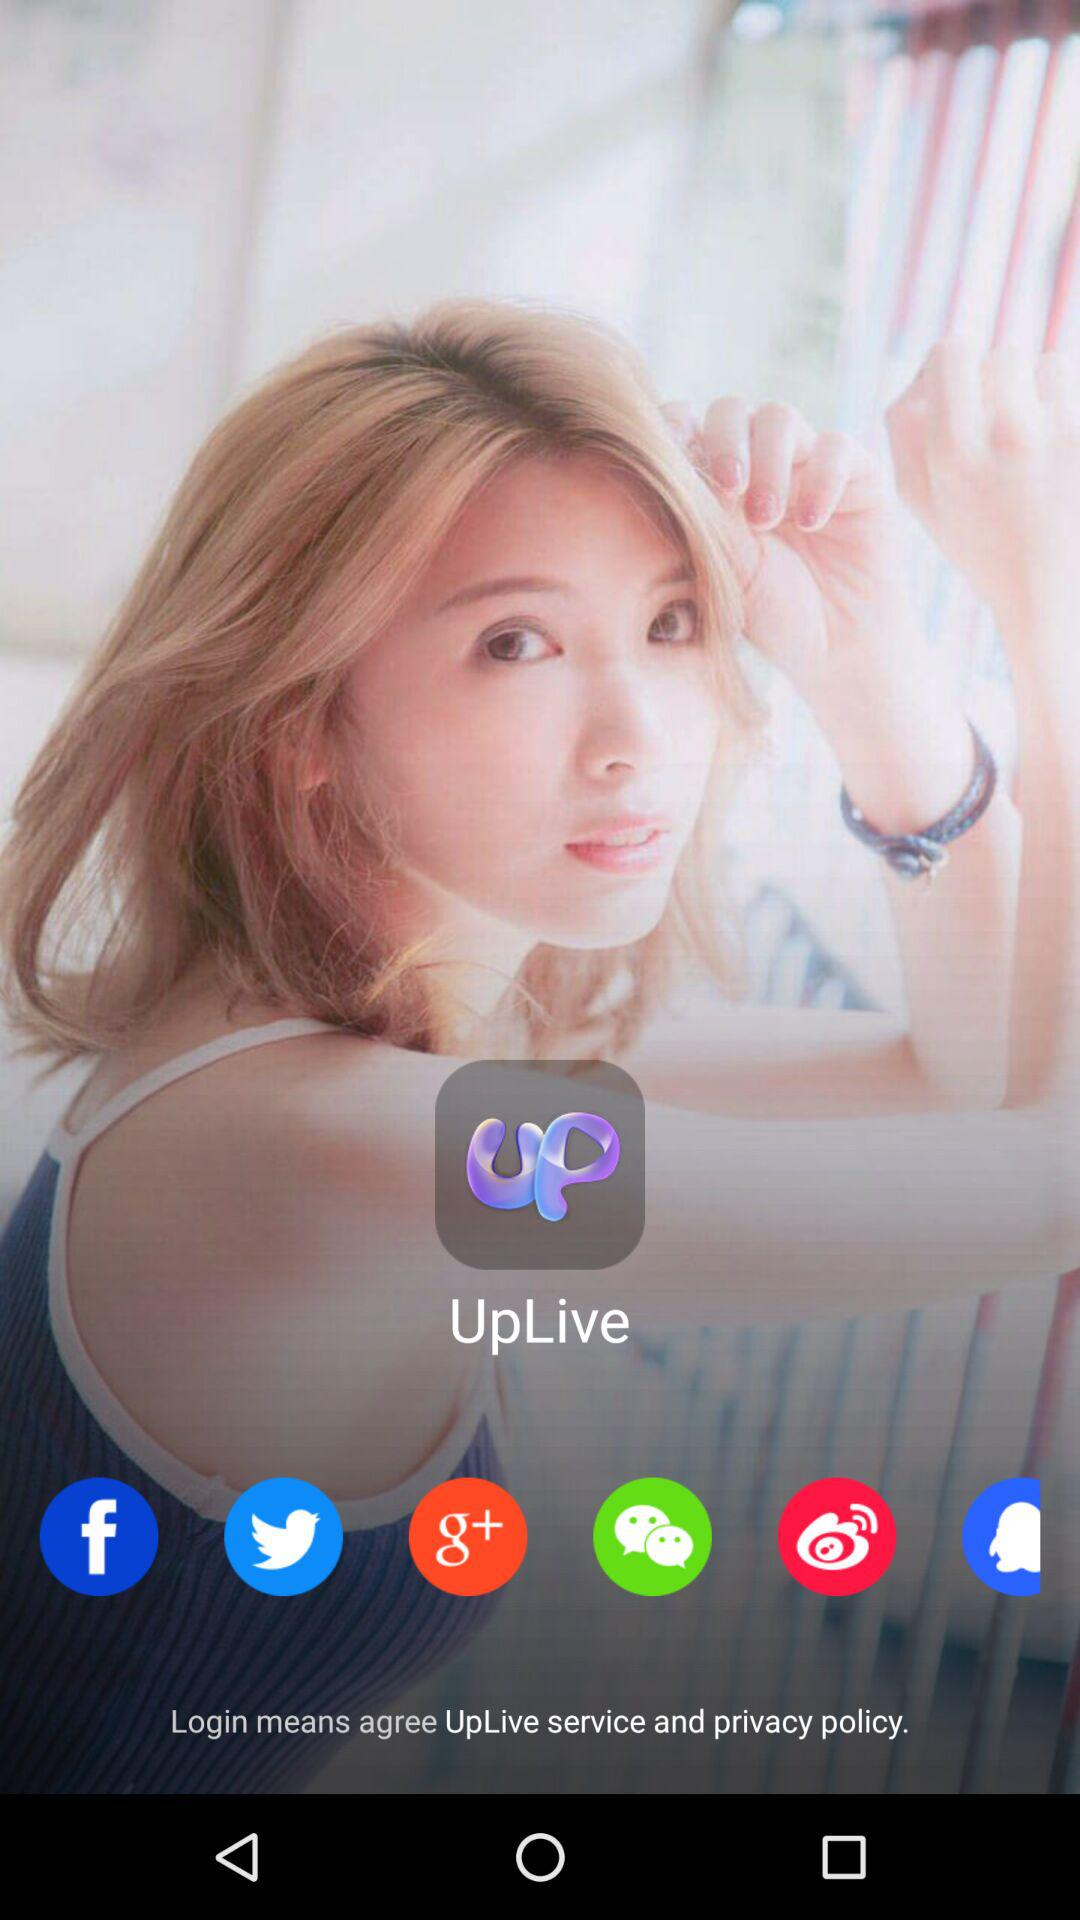How many people use "UpLive"?
When the provided information is insufficient, respond with <no answer>. <no answer> 